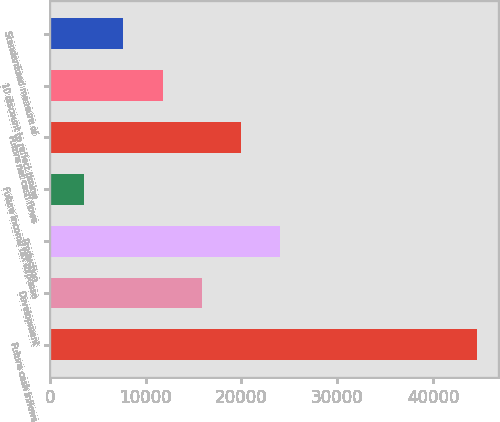Convert chart. <chart><loc_0><loc_0><loc_500><loc_500><bar_chart><fcel>Future cash inflows<fcel>Development<fcel>Production<fcel>Future income tax expense<fcel>Future net cash flows<fcel>10 discount to reflect timing<fcel>Standardized measure of<nl><fcel>44571<fcel>15871.7<fcel>24071.5<fcel>3572<fcel>19971.6<fcel>11771.8<fcel>7671.9<nl></chart> 